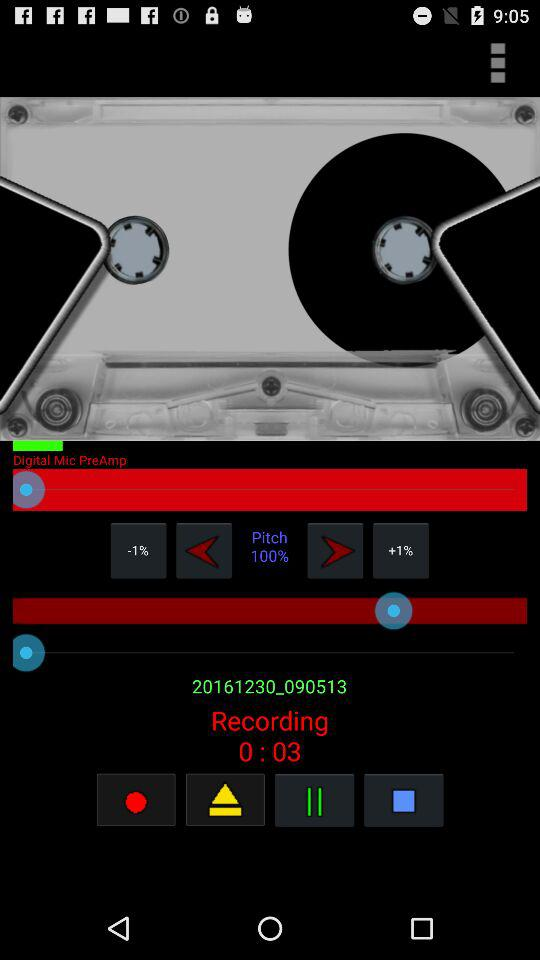What is the pitch of the recording?
Answer the question using a single word or phrase. 100% 